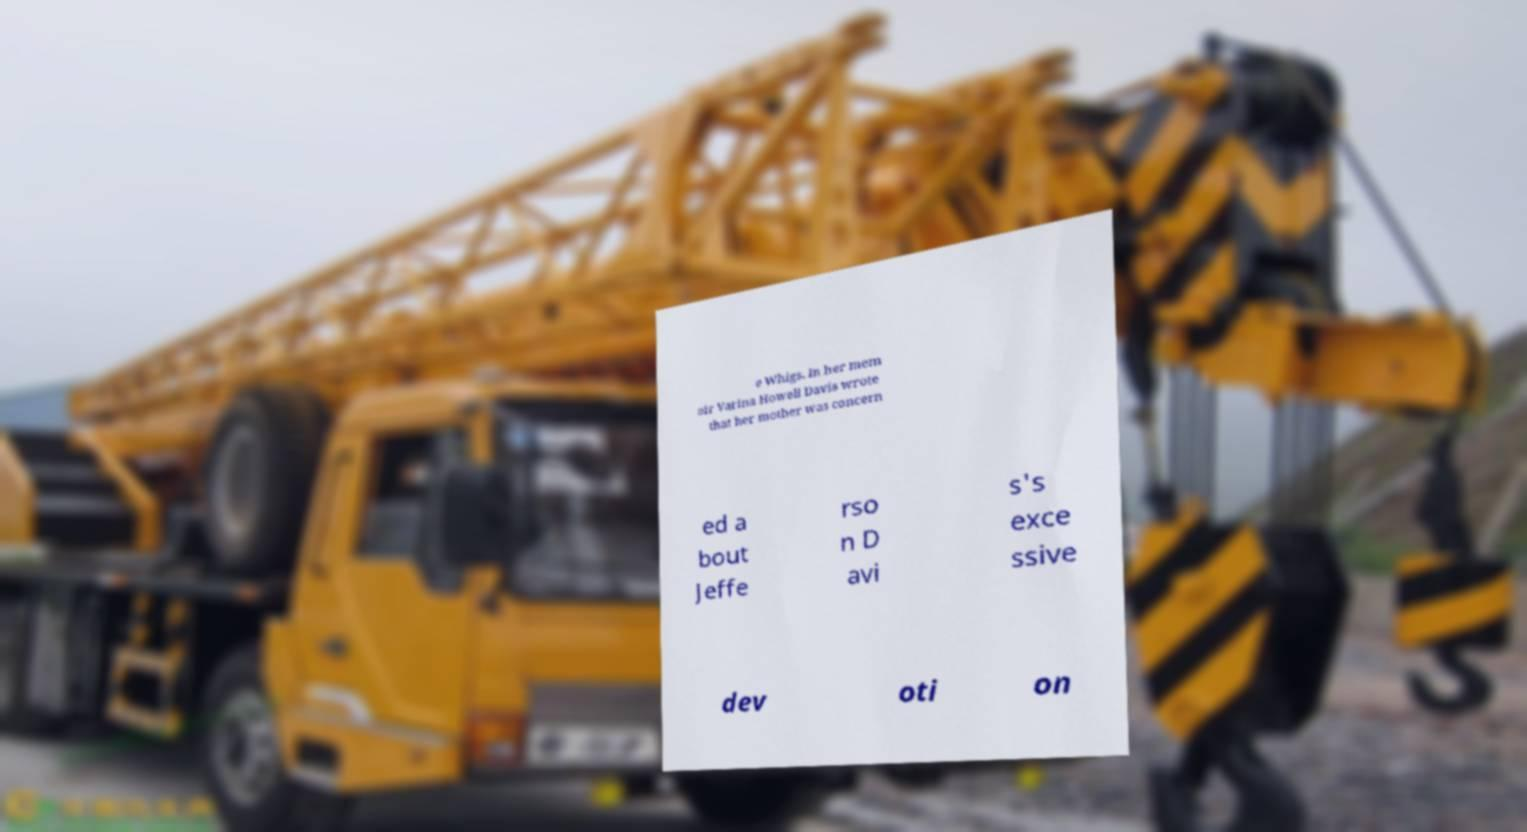Please read and relay the text visible in this image. What does it say? e Whigs. In her mem oir Varina Howell Davis wrote that her mother was concern ed a bout Jeffe rso n D avi s's exce ssive dev oti on 